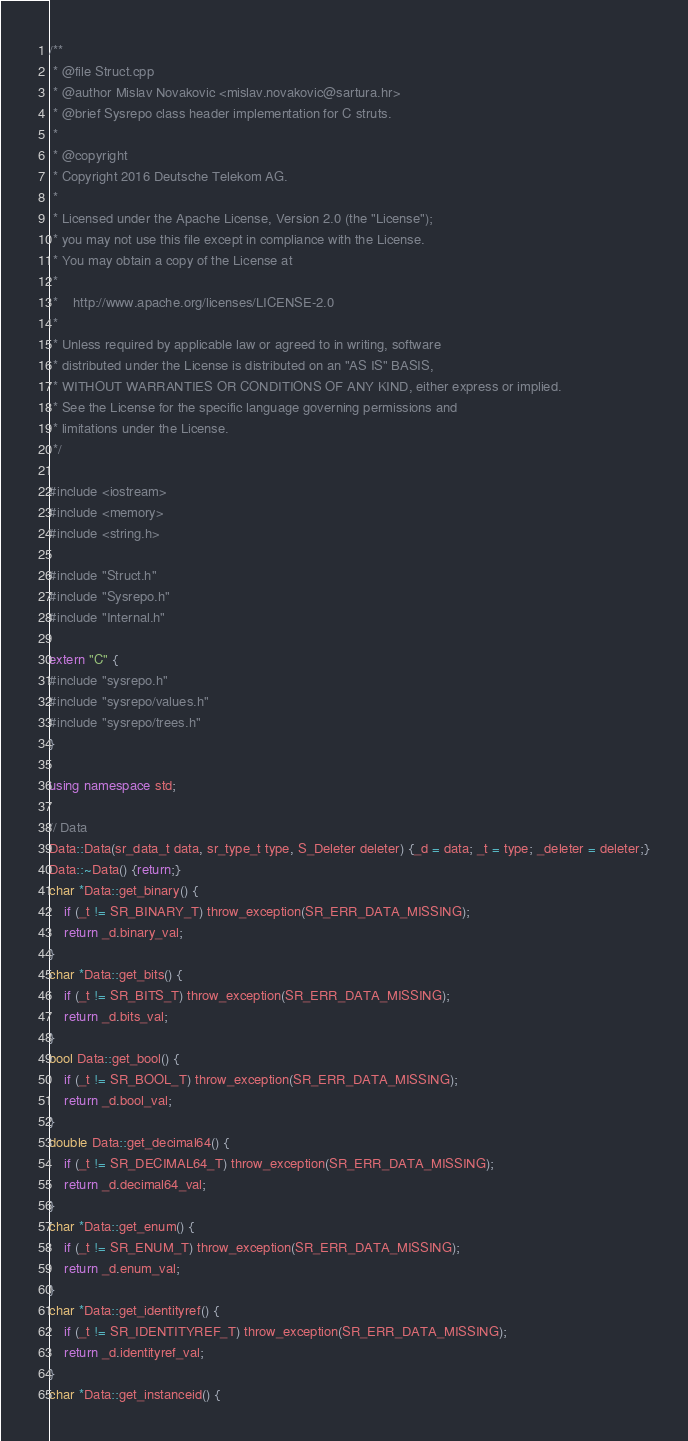Convert code to text. <code><loc_0><loc_0><loc_500><loc_500><_C++_>/**
 * @file Struct.cpp
 * @author Mislav Novakovic <mislav.novakovic@sartura.hr>
 * @brief Sysrepo class header implementation for C struts.
 *
 * @copyright
 * Copyright 2016 Deutsche Telekom AG.
 *
 * Licensed under the Apache License, Version 2.0 (the "License");
 * you may not use this file except in compliance with the License.
 * You may obtain a copy of the License at
 *
 *    http://www.apache.org/licenses/LICENSE-2.0
 *
 * Unless required by applicable law or agreed to in writing, software
 * distributed under the License is distributed on an "AS IS" BASIS,
 * WITHOUT WARRANTIES OR CONDITIONS OF ANY KIND, either express or implied.
 * See the License for the specific language governing permissions and
 * limitations under the License.
 */

#include <iostream>
#include <memory>
#include <string.h>

#include "Struct.h"
#include "Sysrepo.h"
#include "Internal.h"

extern "C" {
#include "sysrepo.h"
#include "sysrepo/values.h"
#include "sysrepo/trees.h"
}

using namespace std;

// Data
Data::Data(sr_data_t data, sr_type_t type, S_Deleter deleter) {_d = data; _t = type; _deleter = deleter;}
Data::~Data() {return;}
char *Data::get_binary() {
    if (_t != SR_BINARY_T) throw_exception(SR_ERR_DATA_MISSING);
    return _d.binary_val;
}
char *Data::get_bits() {
    if (_t != SR_BITS_T) throw_exception(SR_ERR_DATA_MISSING);
    return _d.bits_val;
}
bool Data::get_bool() {
    if (_t != SR_BOOL_T) throw_exception(SR_ERR_DATA_MISSING);
    return _d.bool_val;
}
double Data::get_decimal64() {
    if (_t != SR_DECIMAL64_T) throw_exception(SR_ERR_DATA_MISSING);
    return _d.decimal64_val;
}
char *Data::get_enum() {
    if (_t != SR_ENUM_T) throw_exception(SR_ERR_DATA_MISSING);
    return _d.enum_val;
}
char *Data::get_identityref() {
    if (_t != SR_IDENTITYREF_T) throw_exception(SR_ERR_DATA_MISSING);
    return _d.identityref_val;
}
char *Data::get_instanceid() {</code> 